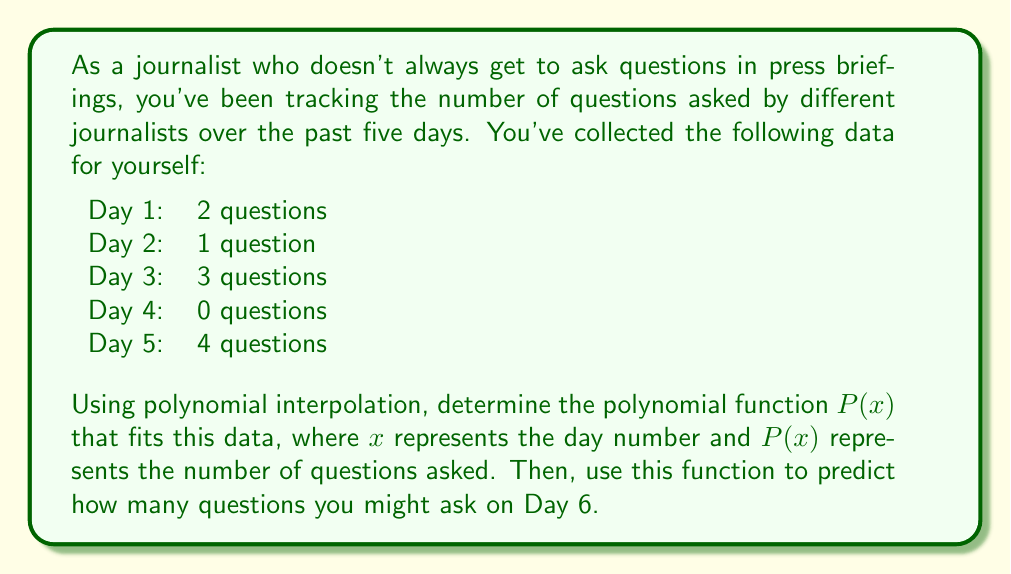Can you solve this math problem? To solve this problem, we'll use Lagrange interpolation to find the polynomial function that fits the given data points. The steps are as follows:

1) For Lagrange interpolation with $n+1$ points, we use a polynomial of degree $n$. Here, we have 5 points, so we'll use a 4th-degree polynomial.

2) The Lagrange interpolation formula is:

   $$P(x) = \sum_{i=0}^n y_i \prod_{j=0, j \neq i}^n \frac{x - x_j}{x_i - x_j}$$

   where $(x_i, y_i)$ are the data points.

3) In our case, we have:
   $(x_0, y_0) = (1, 2)$
   $(x_1, y_1) = (2, 1)$
   $(x_2, y_2) = (3, 3)$
   $(x_3, y_3) = (4, 0)$
   $(x_4, y_4) = (5, 4)$

4) Substituting these into the Lagrange formula:

   $$P(x) = 2\frac{(x-2)(x-3)(x-4)(x-5)}{(1-2)(1-3)(1-4)(1-5)} + 1\frac{(x-1)(x-3)(x-4)(x-5)}{(2-1)(2-3)(2-4)(2-5)} + 3\frac{(x-1)(x-2)(x-4)(x-5)}{(3-1)(3-2)(3-4)(3-5)} + 0\frac{(x-1)(x-2)(x-3)(x-5)}{(4-1)(4-2)(4-3)(4-5)} + 4\frac{(x-1)(x-2)(x-3)(x-4)}{(5-1)(5-2)(5-3)(5-4)}$$

5) Simplifying this expression (which is a tedious process often done by computer), we get:

   $$P(x) = \frac{1}{24}x^4 - \frac{5}{12}x^3 + \frac{35}{24}x^2 - \frac{25}{12}x + 3$$

6) To predict the number of questions for Day 6, we evaluate $P(6)$:

   $$P(6) = \frac{1}{24}(6^4) - \frac{5}{12}(6^3) + \frac{35}{24}(6^2) - \frac{25}{12}(6) + 3 = 9$$
Answer: The polynomial function that fits the data is:

$$P(x) = \frac{1}{24}x^4 - \frac{5}{12}x^3 + \frac{35}{24}x^2 - \frac{25}{12}x + 3$$

Using this function, the predicted number of questions for Day 6 is 9. 